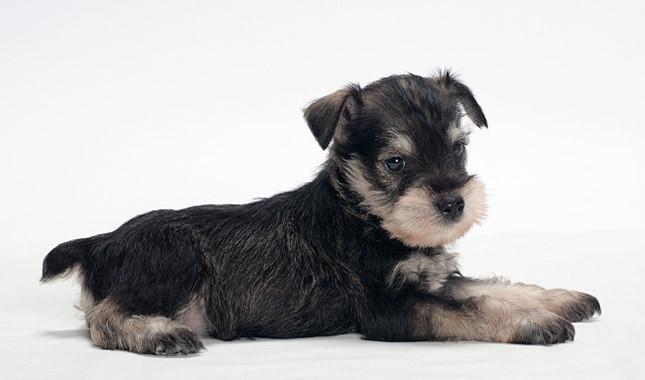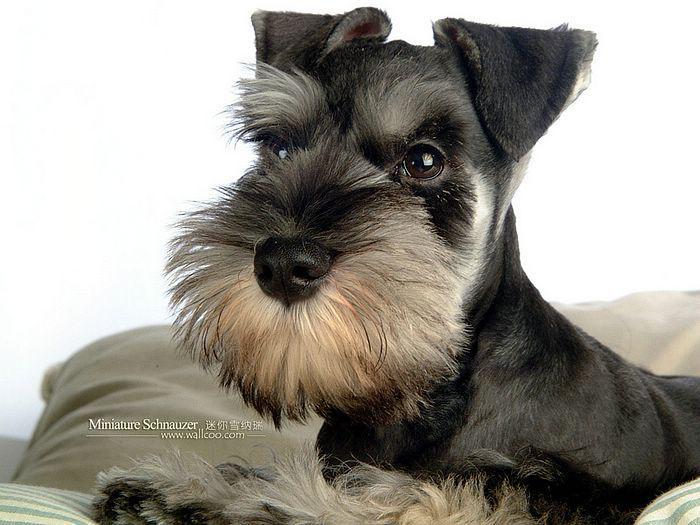The first image is the image on the left, the second image is the image on the right. For the images shown, is this caption "There are two dogs in one of the images." true? Answer yes or no. No. 